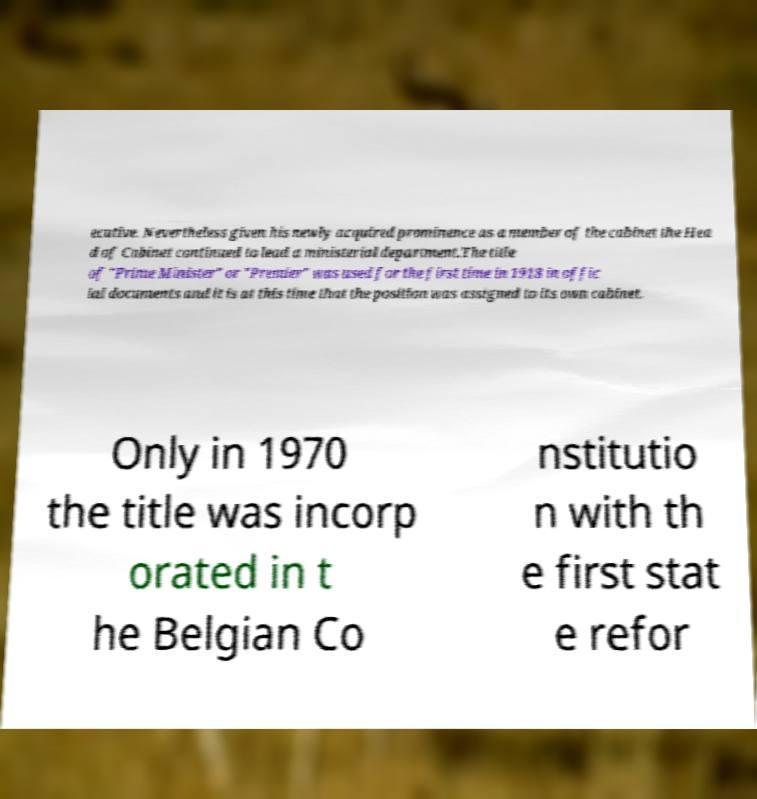Please read and relay the text visible in this image. What does it say? ecutive. Nevertheless given his newly acquired prominence as a member of the cabinet the Hea d of Cabinet continued to lead a ministerial department.The title of "Prime Minister" or "Premier" was used for the first time in 1918 in offic ial documents and it is at this time that the position was assigned to its own cabinet. Only in 1970 the title was incorp orated in t he Belgian Co nstitutio n with th e first stat e refor 